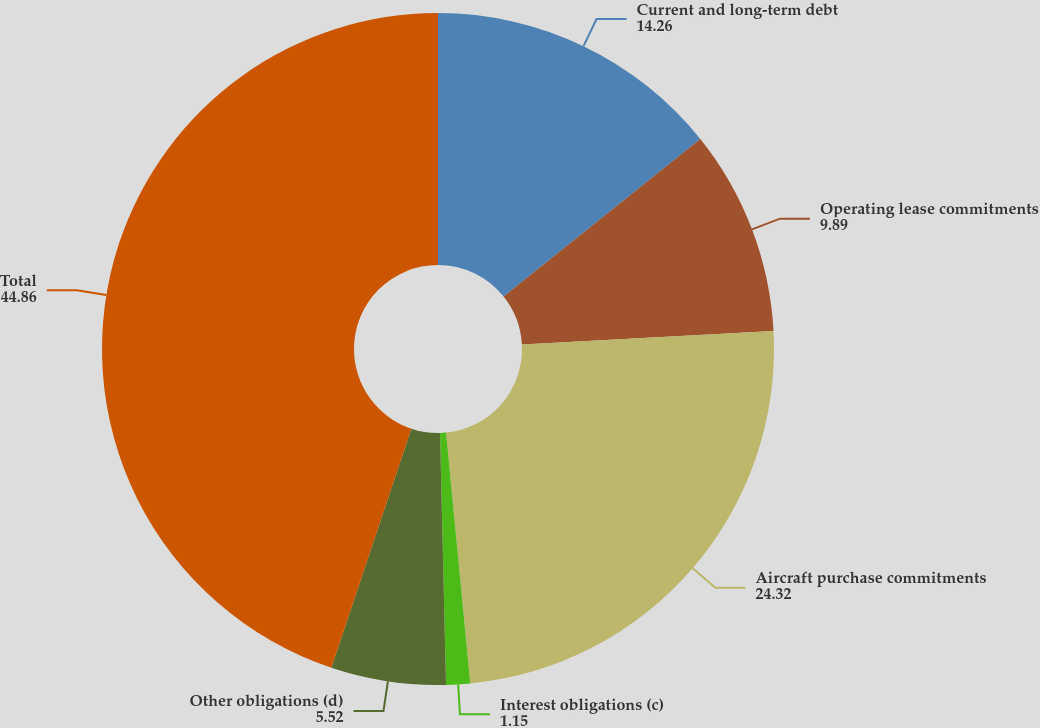<chart> <loc_0><loc_0><loc_500><loc_500><pie_chart><fcel>Current and long-term debt<fcel>Operating lease commitments<fcel>Aircraft purchase commitments<fcel>Interest obligations (c)<fcel>Other obligations (d)<fcel>Total<nl><fcel>14.26%<fcel>9.89%<fcel>24.32%<fcel>1.15%<fcel>5.52%<fcel>44.86%<nl></chart> 